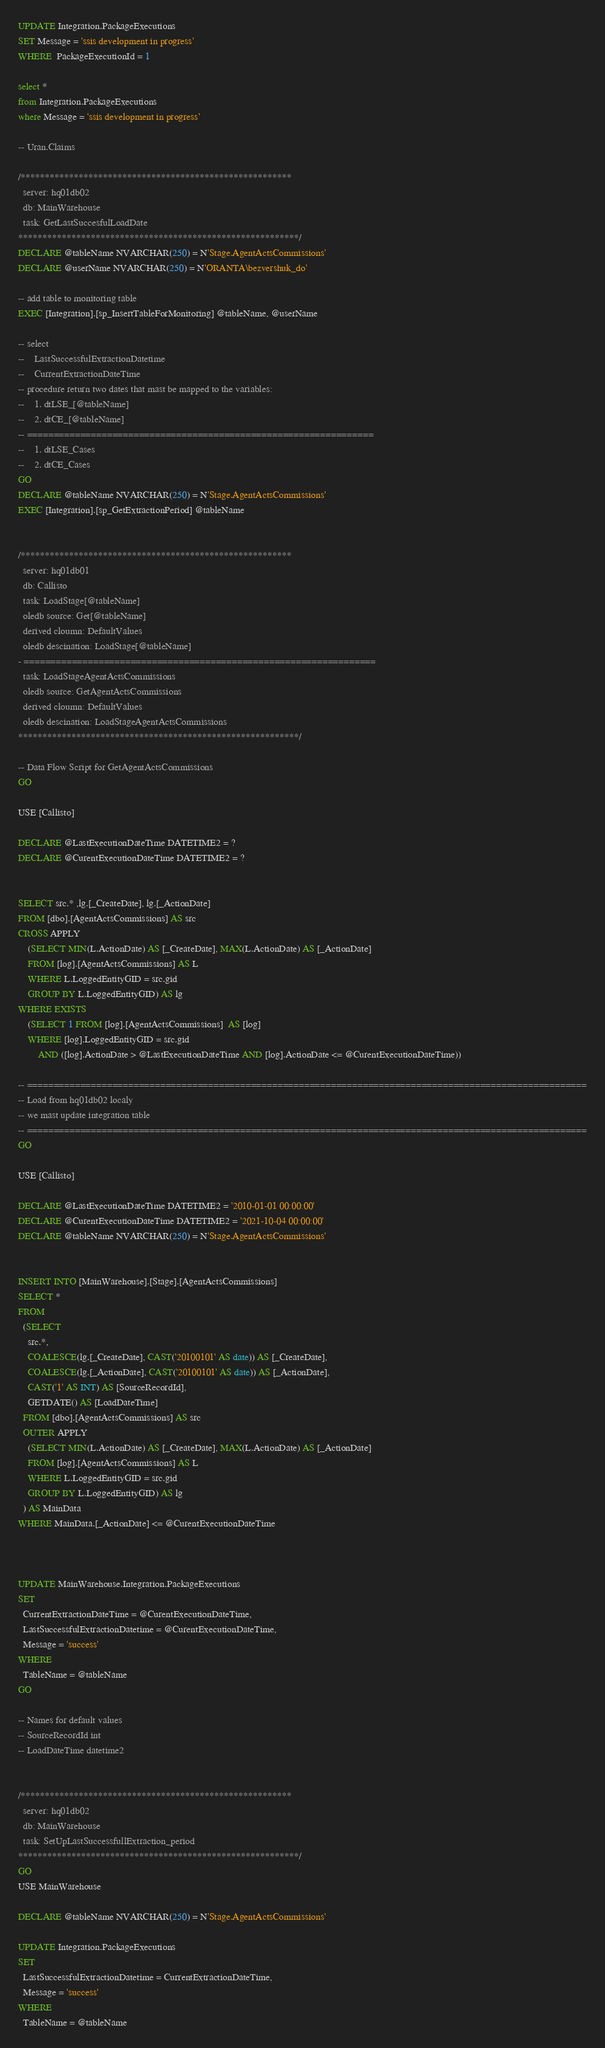<code> <loc_0><loc_0><loc_500><loc_500><_SQL_>UPDATE Integration.PackageExecutions
SET Message = 'ssis development in progress'
WHERE  PackageExecutionId = 1

select *
from Integration.PackageExecutions
where Message = 'ssis development in progress'

-- Uran.Claims

/********************************************************
  server: hq01db02
  db: MainWarehouse
  task: GetLastSuccesfulLoadDate
**********************************************************/
DECLARE @tableName NVARCHAR(250) = N'Stage.AgentActsCommissions'
DECLARE @userName NVARCHAR(250) = N'ORANTA\bezvershuk_do'

-- add table to monitoring table
EXEC [Integration].[sp_InsertTableForMonitoring] @tableName, @userName

-- select 
--    LastSuccessfulExtractionDatetime 
--    CurrentExtractionDateTime
-- procedure return two dates that mast be mapped to the variables:
--    1. dtLSE_[@tableName]
--    2. dtCE_[@tableName]
-- =================================================================
--    1. dtLSE_Cases
--    2. dtCE_Cases
GO
DECLARE @tableName NVARCHAR(250) = N'Stage.AgentActsCommissions'
EXEC [Integration].[sp_GetExtractionPeriod] @tableName


/********************************************************
  server: hq01db01
  db: Callisto
  task: LoadStage[@tableName]
  oledb source: Get[@tableName]
  derived cloumn: DefaultValues
  oledb descination: LoadStage[@tableName]
- ==================================================================
  task: LoadStageAgentActsCommissions
  oledb source: GetAgentActsCommissions
  derived cloumn: DefaultValues
  oledb descination: LoadStageAgentActsCommissions
**********************************************************/

-- Data Flow Script for GetAgentActsCommissions 
GO

USE [Callisto]

DECLARE @LastExecutionDateTime DATETIME2 = ?
DECLARE @CurentExecutionDateTime DATETIME2 = ?


SELECT src.* ,lg.[_CreateDate], lg.[_ActionDate] 
FROM [dbo].[AgentActsCommissions] AS src 
CROSS APPLY 
	(SELECT MIN(L.ActionDate) AS [_CreateDate], MAX(L.ActionDate) AS [_ActionDate] 
	FROM [log].[AgentActsCommissions] AS L 
	WHERE L.LoggedEntityGID = src.gid 
	GROUP BY L.LoggedEntityGID) AS lg 
WHERE EXISTS 
	(SELECT 1 FROM [log].[AgentActsCommissions]  AS [log] 
	WHERE [log].LoggedEntityGID = src.gid 
		AND ([log].ActionDate > @LastExecutionDateTime AND [log].ActionDate <= @CurentExecutionDateTime))

-- =========================================================================================================
-- Load from hq01db02 localy
-- we mast update integration table 
-- =========================================================================================================
GO

USE [Callisto]

DECLARE @LastExecutionDateTime DATETIME2 = '2010-01-01 00:00:00'
DECLARE @CurentExecutionDateTime DATETIME2 = '2021-10-04 00:00:00'
DECLARE @tableName NVARCHAR(250) = N'Stage.AgentActsCommissions'


INSERT INTO [MainWarehouse].[Stage].[AgentActsCommissions]
SELECT *
FROM 
  (SELECT
    src.*,
    COALESCE(lg.[_CreateDate], CAST('20100101' AS date)) AS [_CreateDate], 
    COALESCE(lg.[_ActionDate], CAST('20100101' AS date)) AS [_ActionDate], 
    CAST('1' AS INT) AS [SourceRecordId], 
    GETDATE() AS [LoadDateTime] 
  FROM [dbo].[AgentActsCommissions] AS src 
  OUTER APPLY 
    (SELECT MIN(L.ActionDate) AS [_CreateDate], MAX(L.ActionDate) AS [_ActionDate] 
    FROM [log].[AgentActsCommissions] AS L 
    WHERE L.LoggedEntityGID = src.gid 
    GROUP BY L.LoggedEntityGID) AS lg
  ) AS MainData
WHERE MainData.[_ActionDate] <= @CurentExecutionDateTime



UPDATE MainWarehouse.Integration.PackageExecutions
SET 
  CurrentExtractionDateTime = @CurentExecutionDateTime,
  LastSuccessfulExtractionDatetime = @CurentExecutionDateTime,
  Message = 'success'
WHERE
  TableName = @tableName
GO

-- Names for default values 
-- SourceRecordId int
-- LoadDateTime datetime2


/********************************************************
  server: hq01db02
  db: MainWarehouse
  task: SetUpLastSuccessfullExtraction_period
**********************************************************/
GO
USE MainWarehouse

DECLARE @tableName NVARCHAR(250) = N'Stage.AgentActsCommissions'

UPDATE Integration.PackageExecutions
SET 
  LastSuccessfulExtractionDatetime = CurrentExtractionDateTime,
  Message = 'success'
WHERE
  TableName = @tableName

</code> 